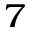<formula> <loc_0><loc_0><loc_500><loc_500>^ { 7 }</formula> 